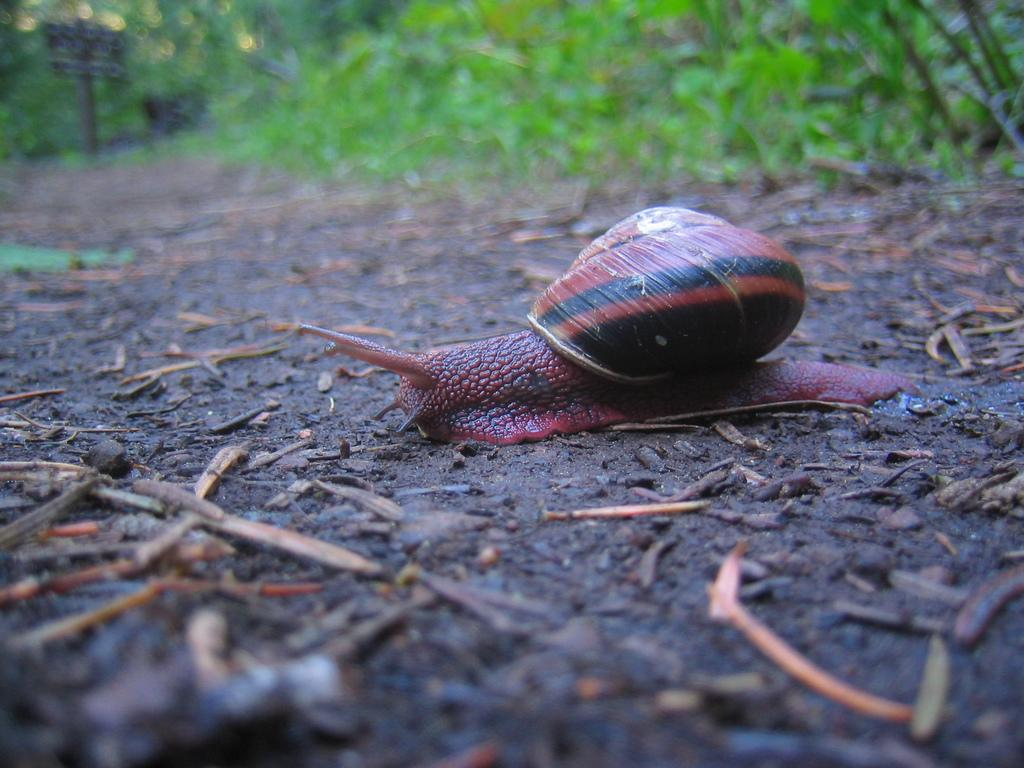What type of animal is on the ground in the image? There is a snail on the ground in the image. What else can be found on the ground in the image? There are sticks and leaves on the ground in the image. What type of vegetation is present in the image? There are plants and bushes in the image. What type of picture is being protested against in the image? There is no picture or protest present in the image; it features a snail, sticks, leaves, plants, and bushes. 